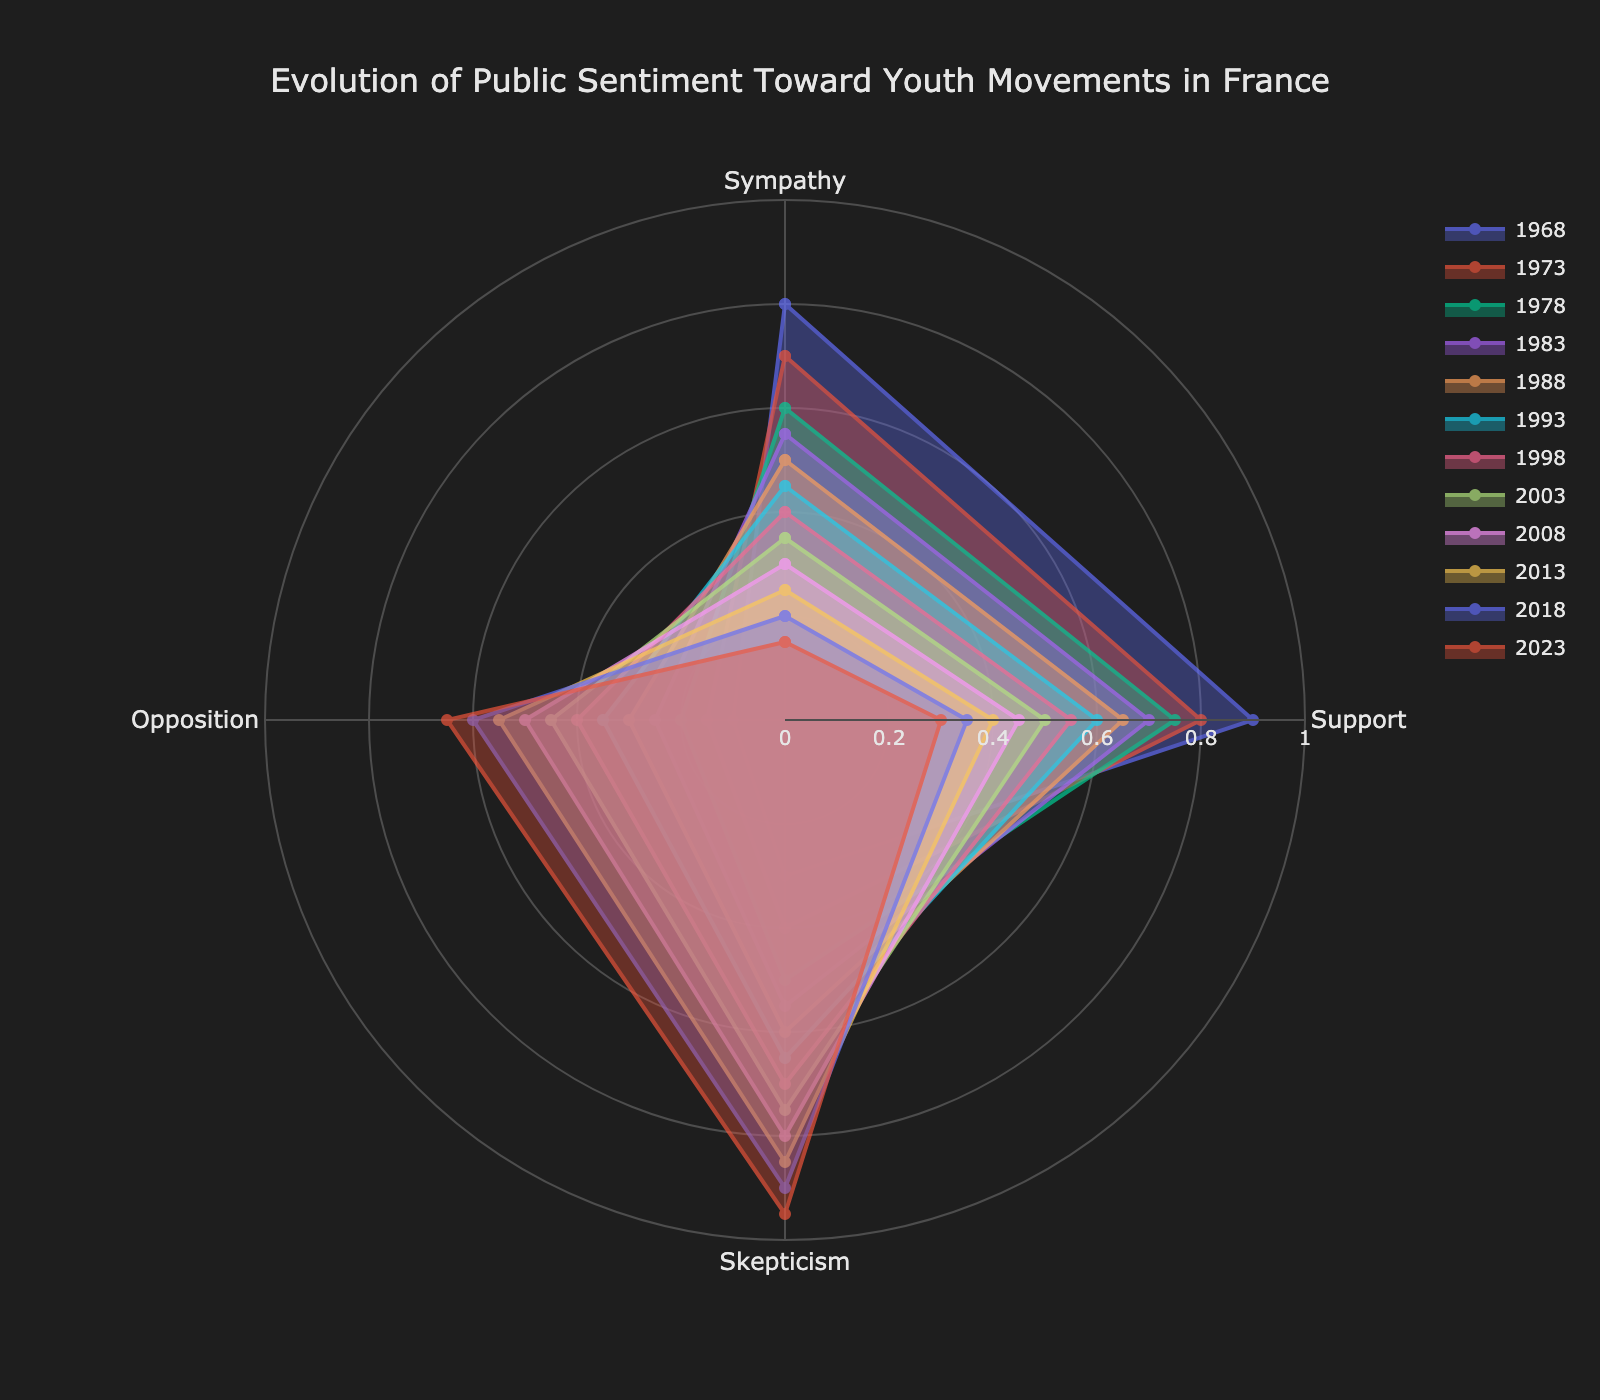What is the title of the figure? The title of the figure is the text at the top, which summarizes what the graph represents.
Answer: Evolution of Public Sentiment Toward Youth Movements in France How many categories of sentiment are shown in the figure? Count the uniquely labeled axes used to represent different sentiments towards youth movements.
Answer: Four Which category shows a consistently increasing trend from 1968 to 2023? Observe the direction of the lines representing different years for each sentiment category to identify the one that increases over time.
Answer: Skepticism In 1968, which sentiment had the highest value? Look at the 1968 trace and identify which category has the highest value among Sympathy, Support, Skepticism, and Opposition.
Answer: Support Why do the polygons have different shapes? Different shapes result from varying values of the sentiment categories for each year, influencing the plotting of the vertices on the polar chart differently.
Answer: Different sentiment values over the years Which sentiment shows the greatest decrease from 1968 to 2023? Compare the values of each sentiment category for the years 1968 and 2023, and identify the category with the largest difference.
Answer: Support Between the years 1983 and 1993, how does the sentiment of Skepticism change? Identify the values for Skepticism in 1983 and 1993, and determine if it increased or decreased.
Answer: Increased In 2008, what was the value of Sympathy? Locate the 2008 trace and read off the value corresponding to the Sympathy category.
Answer: 0.3 In which year did Opposition reach 0.6? Find the year for which the trace touches 0.6 on the Opposition axis.
Answer: 2018 Which year had the closest values for Sympathy and Opposition? Compare the Sympathy and Opposition values for each year and find the year where the values are closest to each other.
Answer: 2023 